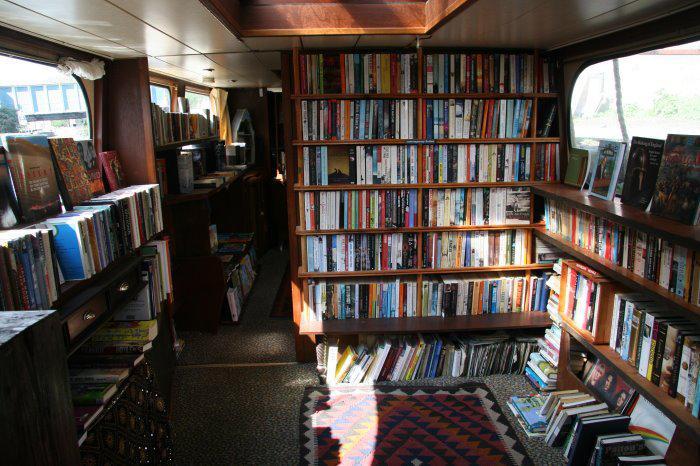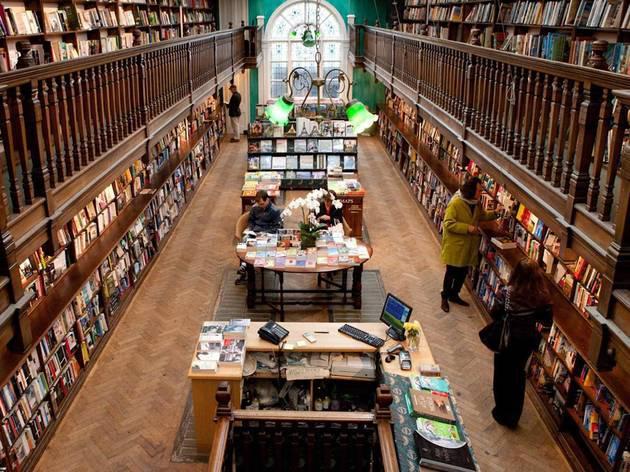The first image is the image on the left, the second image is the image on the right. Considering the images on both sides, is "In one image, at least one person is inside a book store that has books shelved to the ceiling." valid? Answer yes or no. Yes. The first image is the image on the left, the second image is the image on the right. For the images displayed, is the sentence "Both images include book shop exteriors." factually correct? Answer yes or no. No. 